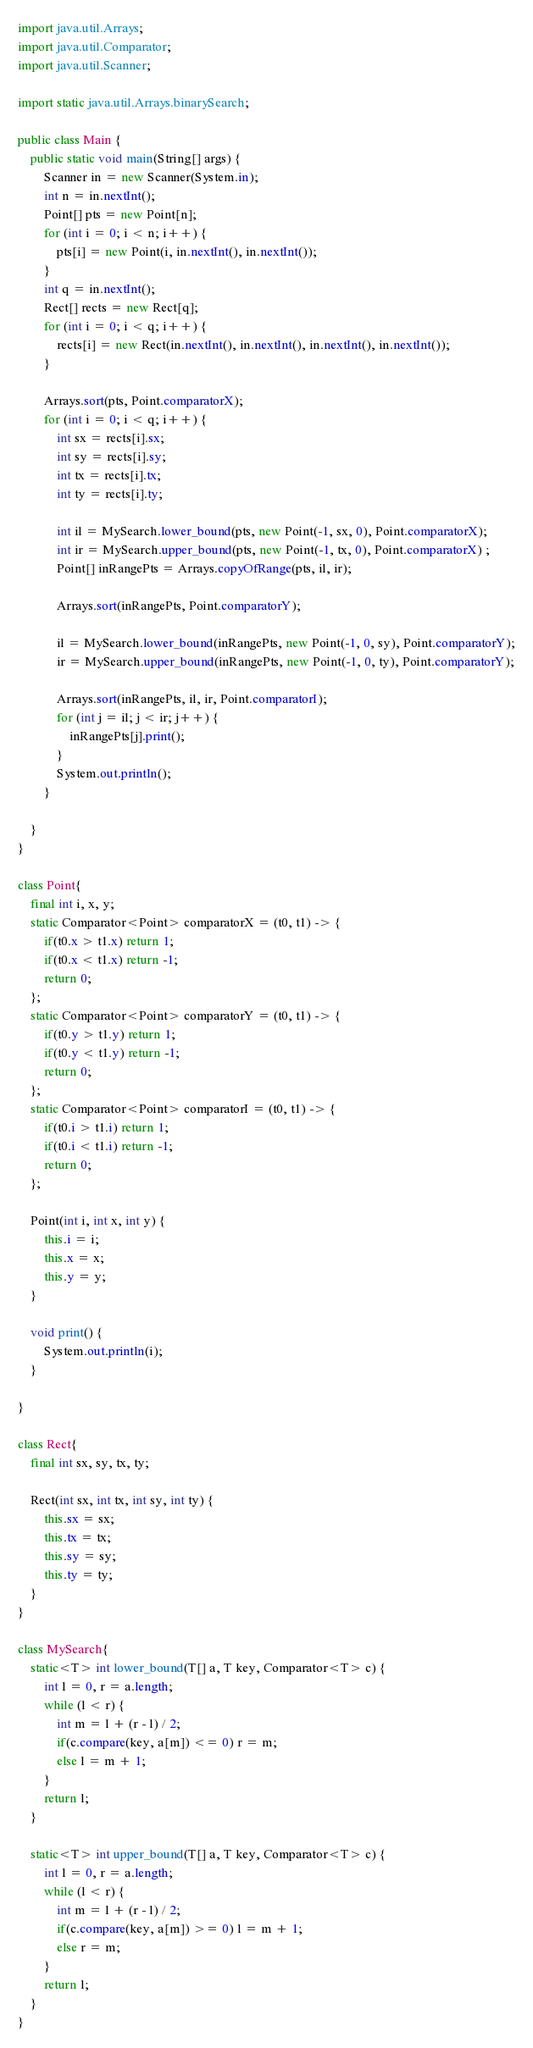<code> <loc_0><loc_0><loc_500><loc_500><_Java_>import java.util.Arrays;
import java.util.Comparator;
import java.util.Scanner;

import static java.util.Arrays.binarySearch;

public class Main {
    public static void main(String[] args) {
        Scanner in = new Scanner(System.in);
        int n = in.nextInt();
        Point[] pts = new Point[n];
        for (int i = 0; i < n; i++) {
            pts[i] = new Point(i, in.nextInt(), in.nextInt());
        }
        int q = in.nextInt();
        Rect[] rects = new Rect[q];
        for (int i = 0; i < q; i++) {
            rects[i] = new Rect(in.nextInt(), in.nextInt(), in.nextInt(), in.nextInt());
        }

        Arrays.sort(pts, Point.comparatorX);
        for (int i = 0; i < q; i++) {
            int sx = rects[i].sx;
            int sy = rects[i].sy;
            int tx = rects[i].tx;
            int ty = rects[i].ty;

            int il = MySearch.lower_bound(pts, new Point(-1, sx, 0), Point.comparatorX);
            int ir = MySearch.upper_bound(pts, new Point(-1, tx, 0), Point.comparatorX) ;
            Point[] inRangePts = Arrays.copyOfRange(pts, il, ir);

            Arrays.sort(inRangePts, Point.comparatorY);

            il = MySearch.lower_bound(inRangePts, new Point(-1, 0, sy), Point.comparatorY);
            ir = MySearch.upper_bound(inRangePts, new Point(-1, 0, ty), Point.comparatorY);

            Arrays.sort(inRangePts, il, ir, Point.comparatorI);
            for (int j = il; j < ir; j++) {
                inRangePts[j].print();
            }
            System.out.println();
        }

    }
}

class Point{
    final int i, x, y;
    static Comparator<Point> comparatorX = (t0, t1) -> {
        if(t0.x > t1.x) return 1;
        if(t0.x < t1.x) return -1;
        return 0;
    };
    static Comparator<Point> comparatorY = (t0, t1) -> {
        if(t0.y > t1.y) return 1;
        if(t0.y < t1.y) return -1;
        return 0;
    };
    static Comparator<Point> comparatorI = (t0, t1) -> {
        if(t0.i > t1.i) return 1;
        if(t0.i < t1.i) return -1;
        return 0;
    };

    Point(int i, int x, int y) {
        this.i = i;
        this.x = x;
        this.y = y;
    }

    void print() {
        System.out.println(i);
    }

}

class Rect{
    final int sx, sy, tx, ty;

    Rect(int sx, int tx, int sy, int ty) {
        this.sx = sx;
        this.tx = tx;
        this.sy = sy;
        this.ty = ty;
    }
}

class MySearch{
    static<T> int lower_bound(T[] a, T key, Comparator<T> c) {
        int l = 0, r = a.length;
        while (l < r) {
            int m = l + (r - l) / 2;
            if(c.compare(key, a[m]) <= 0) r = m;
            else l = m + 1;
        }
        return l;
    }

    static<T> int upper_bound(T[] a, T key, Comparator<T> c) {
        int l = 0, r = a.length;
        while (l < r) {
            int m = l + (r - l) / 2;
            if(c.compare(key, a[m]) >= 0) l = m + 1;
            else r = m;
        }
        return l;
    }
}
</code> 